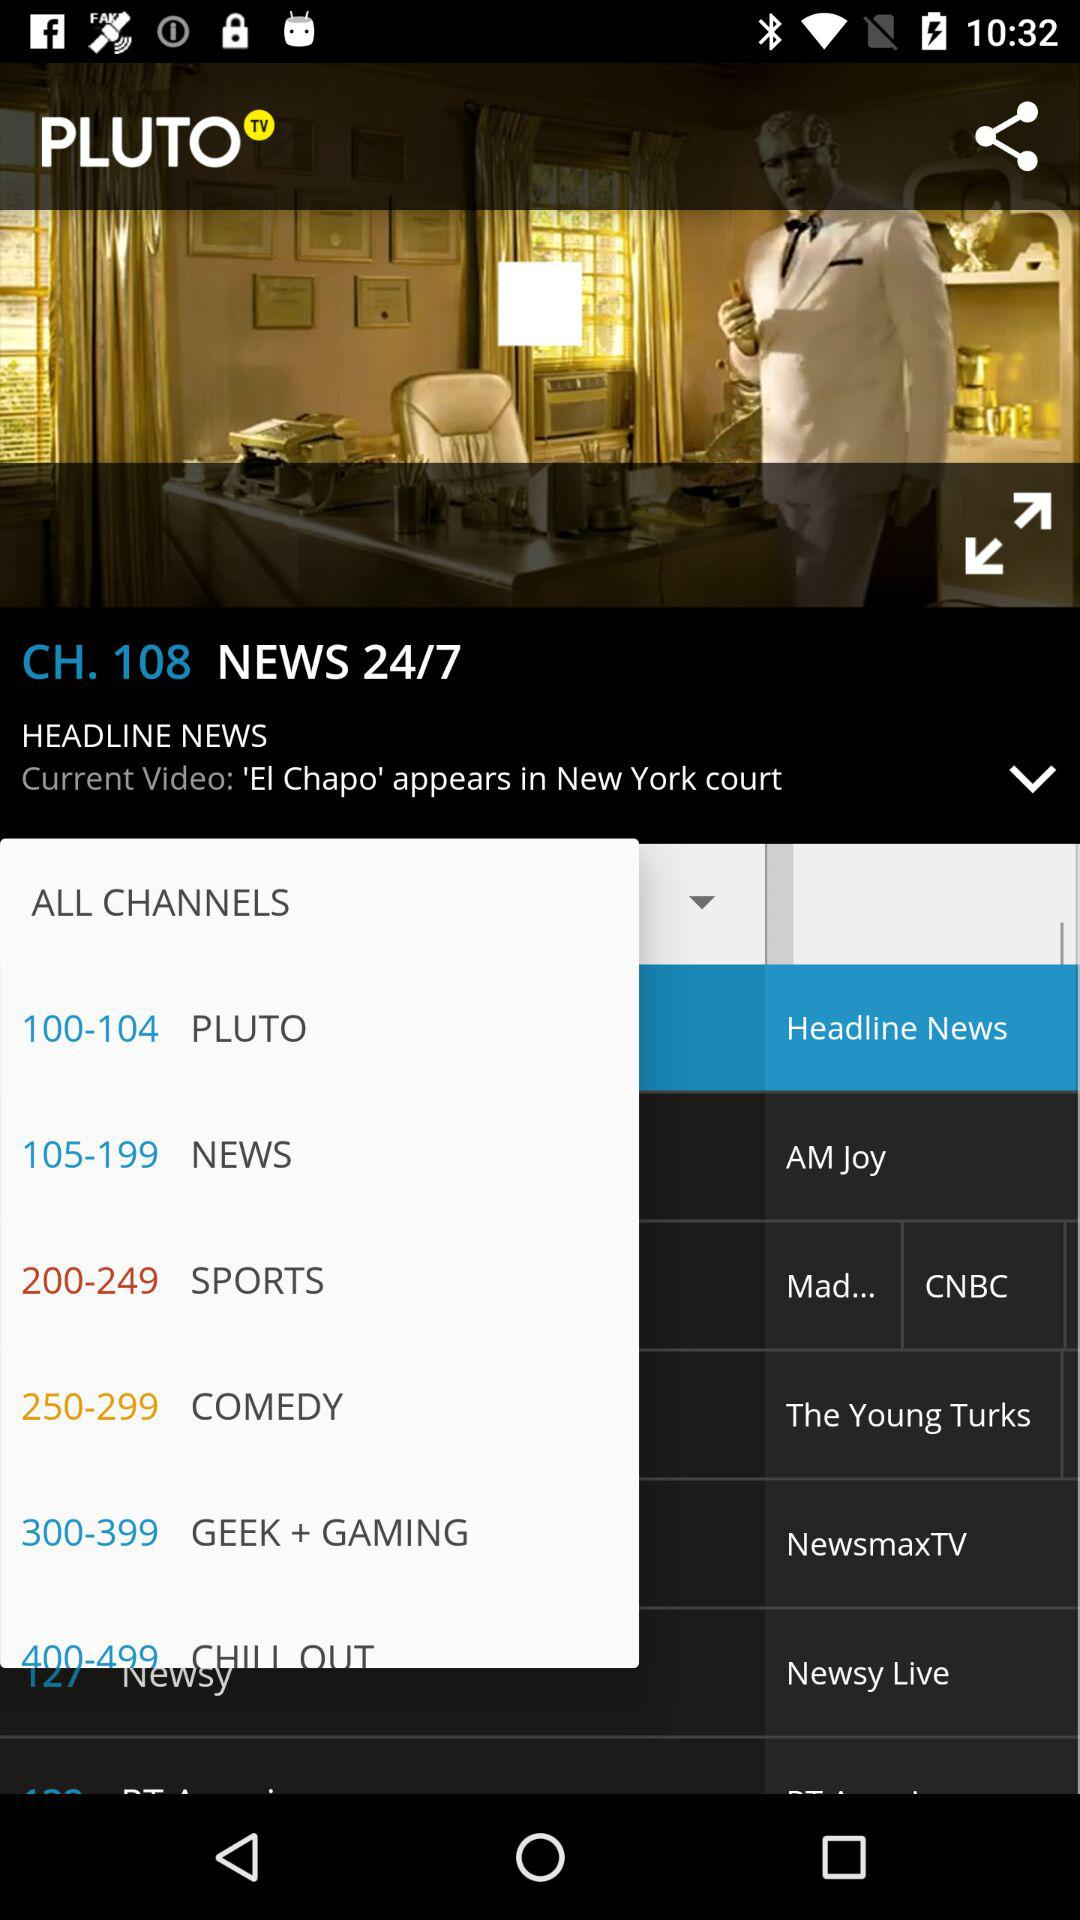What time did the program begin?
When the provided information is insufficient, respond with <no answer>. <no answer> 